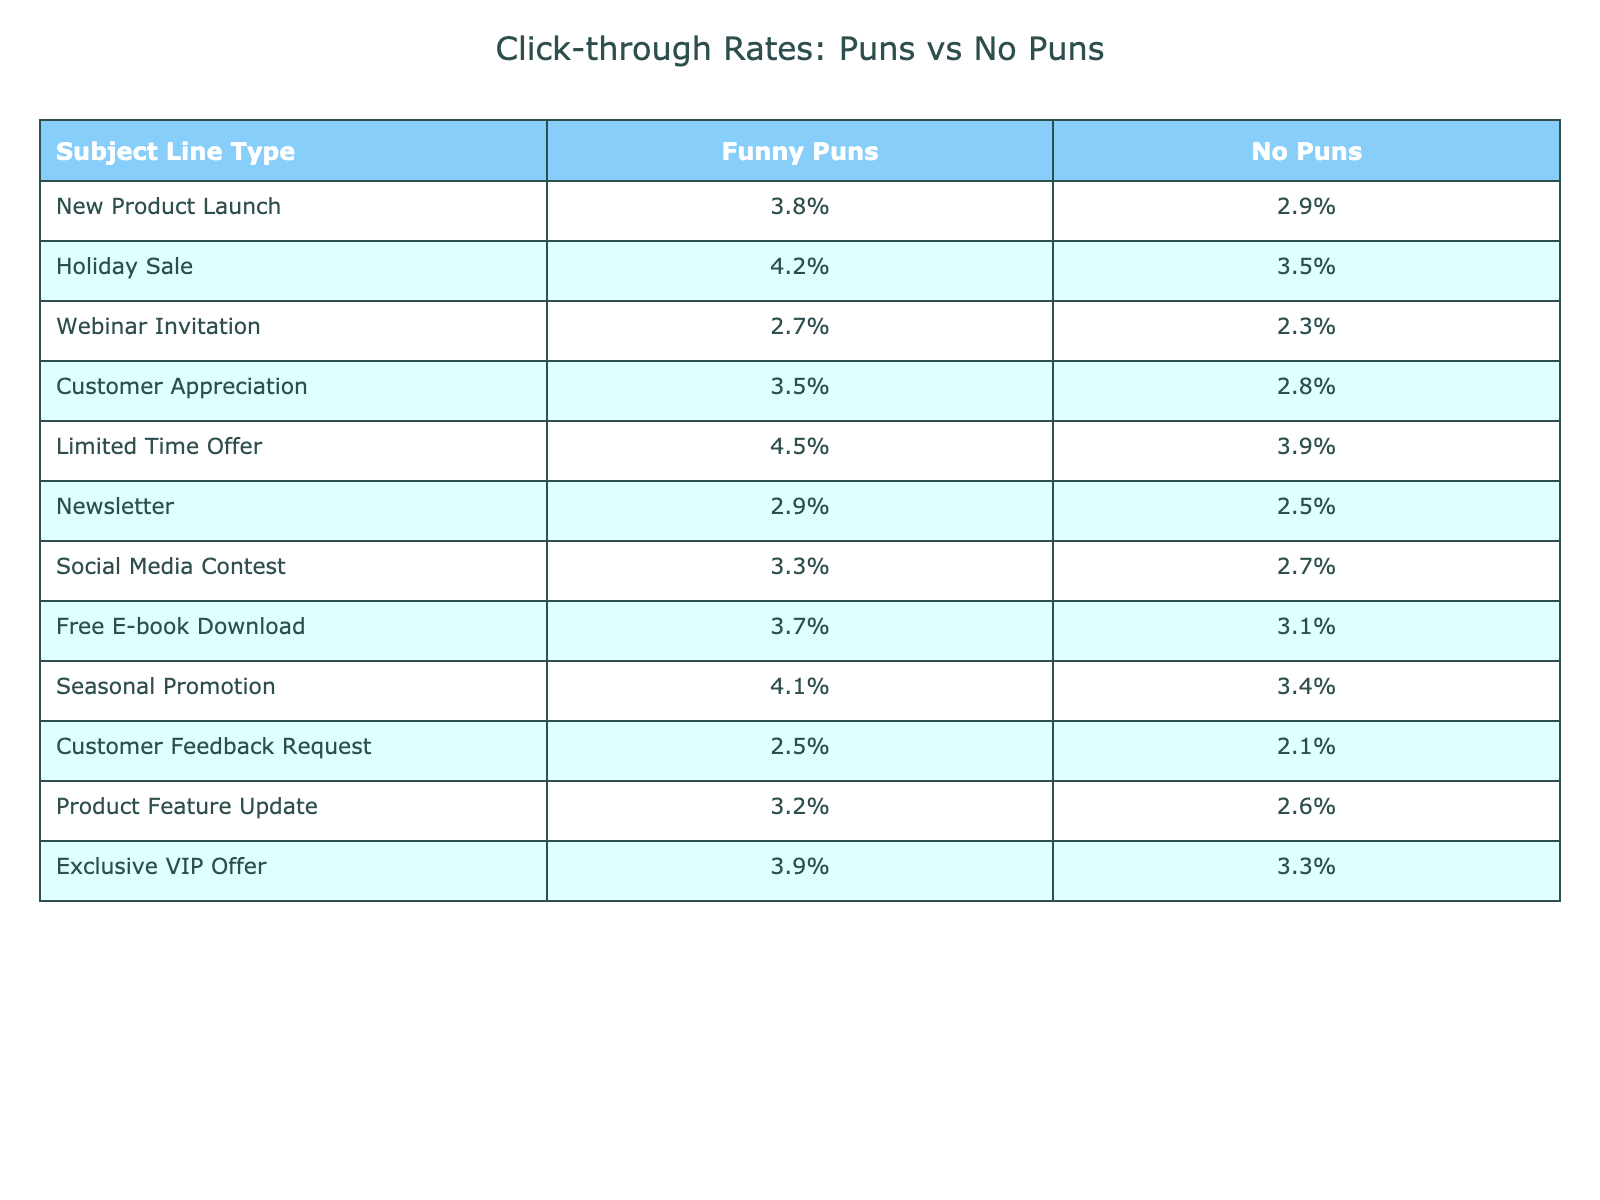What is the click-through rate for the Holiday Sale with puns? The table shows that the click-through rate for the Holiday Sale with puns is 4.2%.
Answer: 4.2% Which subject line type has the highest click-through rate with no puns? By examining the "No Puns" column in the table, the Limited Time Offer has the highest click-through rate of 3.9%.
Answer: 3.9% What is the difference in click-through rates for the New Product Launch between funny puns and no puns? The click-through rate for New Product Launch with puns is 3.8%, and without puns, it is 2.9%. The difference is 3.8% - 2.9% = 0.9%.
Answer: 0.9% What is the average click-through rate for all subject lines with funny puns? To find the average, sum all the "Funny Puns" values: (3.8% + 4.2% + 2.7% + 3.5% + 4.5% + 2.9% + 3.3% + 3.7% + 4.1% + 2.5% + 3.2% + 3.9%) = 43.7%, and divide by 12, so the average is about 3.64%.
Answer: 3.64% Is the click-through rate for the Customer Appreciation subject line higher with puns compared to without puns? The click-through rate for Customer Appreciation with puns is 3.5% and without puns is 2.8%. Since 3.5% is greater than 2.8%, the statement is true.
Answer: Yes Which subject line type experienced the smallest difference between its click-through rates with puns versus without? Analyzing the differences, the smallest difference is found in the Webinar Invitation, where the rates are 2.7% (with puns) and 2.3% (without), giving a difference of 0.4%.
Answer: Webinar Invitation How many subject lines have a click-through rate of 4% or higher with funny puns? Looking at the "Funny Puns" column, the subject lines with rates of 4% or higher are: Holiday Sale, Limited Time Offer, and Seasonal Promotion. That's a total of 3 subject lines.
Answer: 3 What is the overall trend in click-through rates for subject lines with puns compared to those without? By reviewing the data, the majority of subject lines show higher click-through rates with puns compared to those without, indicating a positive trend for the use of puns in subject lines.
Answer: Higher with puns Which subject line has the lowest click-through rate with no puns? From the "No Puns" column, the Customer Feedback Request has the lowest click-through rate at 2.1%.
Answer: 2.1% 